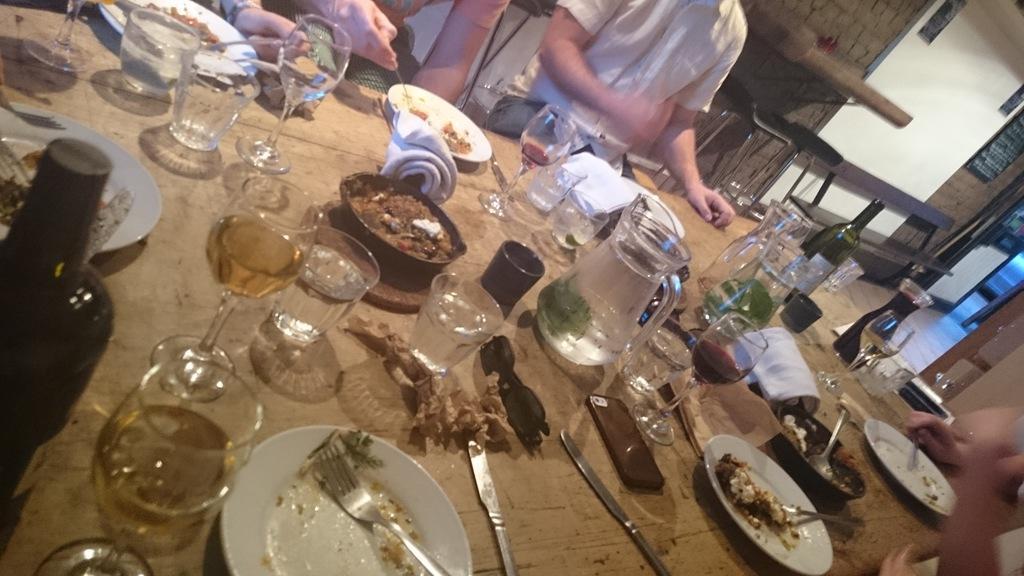Can you describe this image briefly? In this image we can see a table. on the table there are cutlery, crockery, mobile phones, beverage bottles and napkins. In the background we can see persons sitting on the chairs, benches, walls, doors, floor and wall hangings. 